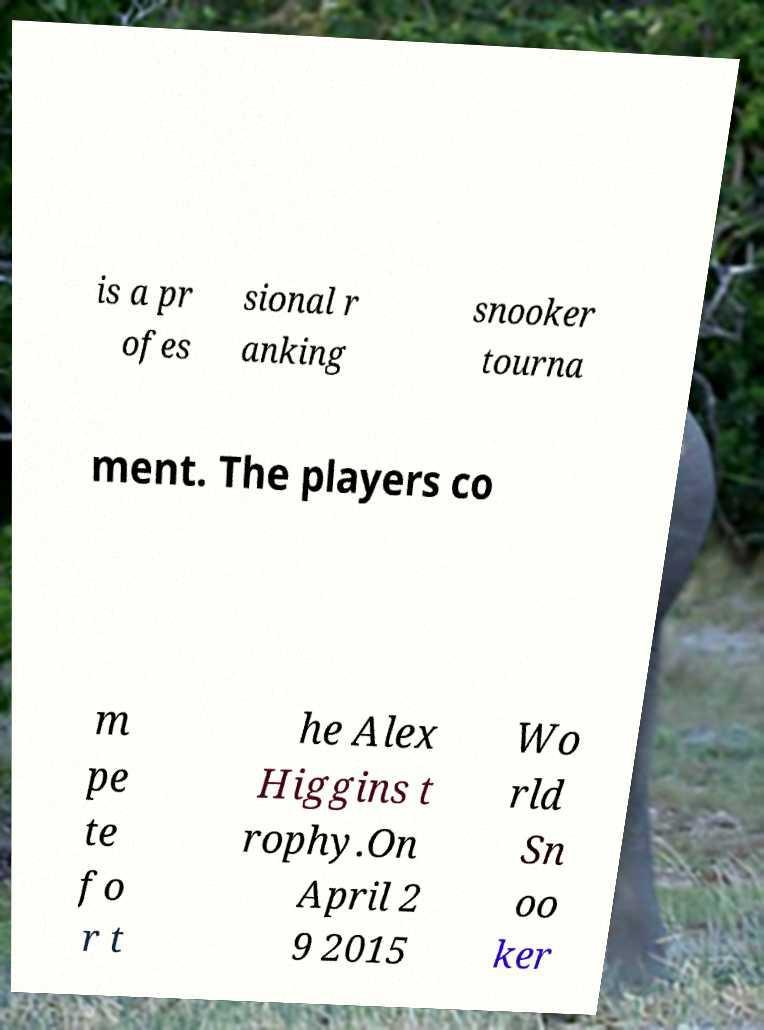Can you accurately transcribe the text from the provided image for me? is a pr ofes sional r anking snooker tourna ment. The players co m pe te fo r t he Alex Higgins t rophy.On April 2 9 2015 Wo rld Sn oo ker 